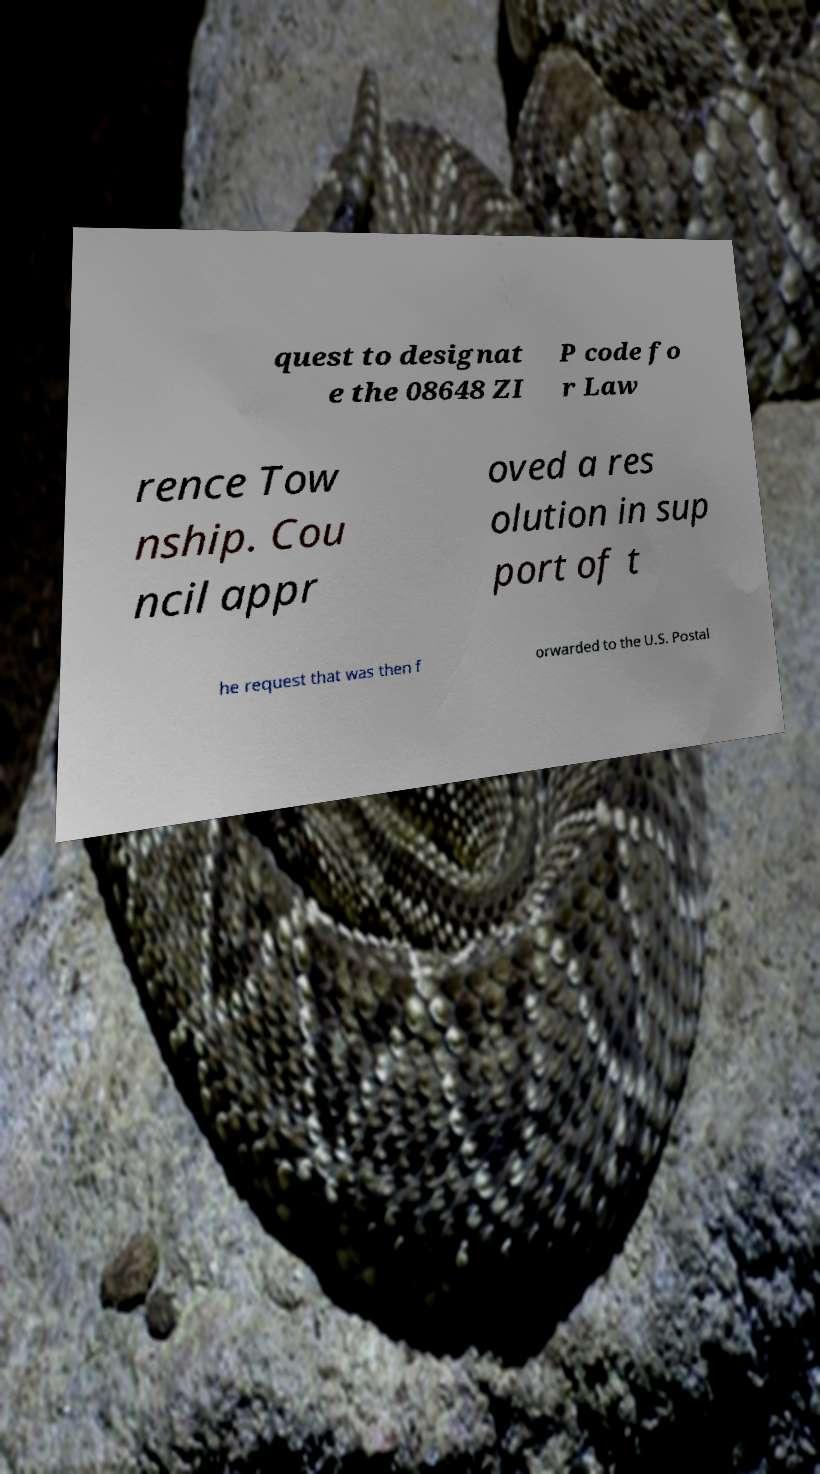Please read and relay the text visible in this image. What does it say? quest to designat e the 08648 ZI P code fo r Law rence Tow nship. Cou ncil appr oved a res olution in sup port of t he request that was then f orwarded to the U.S. Postal 